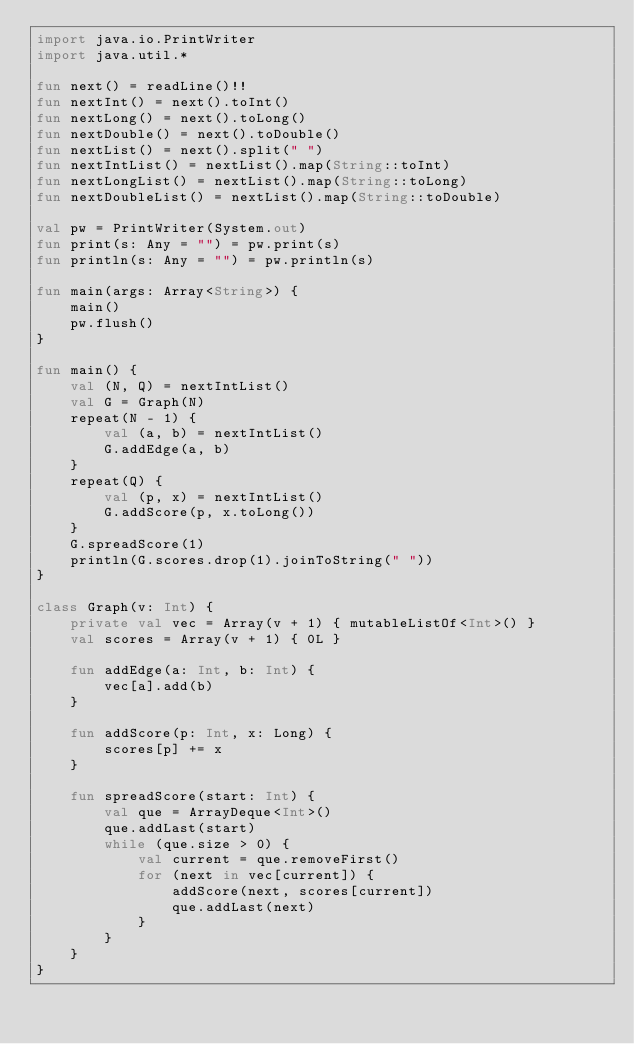Convert code to text. <code><loc_0><loc_0><loc_500><loc_500><_Kotlin_>import java.io.PrintWriter
import java.util.*

fun next() = readLine()!!
fun nextInt() = next().toInt()
fun nextLong() = next().toLong()
fun nextDouble() = next().toDouble()
fun nextList() = next().split(" ")
fun nextIntList() = nextList().map(String::toInt)
fun nextLongList() = nextList().map(String::toLong)
fun nextDoubleList() = nextList().map(String::toDouble)

val pw = PrintWriter(System.out)
fun print(s: Any = "") = pw.print(s)
fun println(s: Any = "") = pw.println(s)

fun main(args: Array<String>) {
    main()
    pw.flush()
}

fun main() {
    val (N, Q) = nextIntList()
    val G = Graph(N)
    repeat(N - 1) {
        val (a, b) = nextIntList()
        G.addEdge(a, b)
    }
    repeat(Q) {
        val (p, x) = nextIntList()
        G.addScore(p, x.toLong())
    }
    G.spreadScore(1)
    println(G.scores.drop(1).joinToString(" "))
}

class Graph(v: Int) {
    private val vec = Array(v + 1) { mutableListOf<Int>() }
    val scores = Array(v + 1) { 0L }

    fun addEdge(a: Int, b: Int) {
        vec[a].add(b)
    }

    fun addScore(p: Int, x: Long) {
        scores[p] += x
    }

    fun spreadScore(start: Int) {
        val que = ArrayDeque<Int>()
        que.addLast(start)
        while (que.size > 0) {
            val current = que.removeFirst()
            for (next in vec[current]) {
                addScore(next, scores[current])
                que.addLast(next)
            }
        }
    }
}</code> 